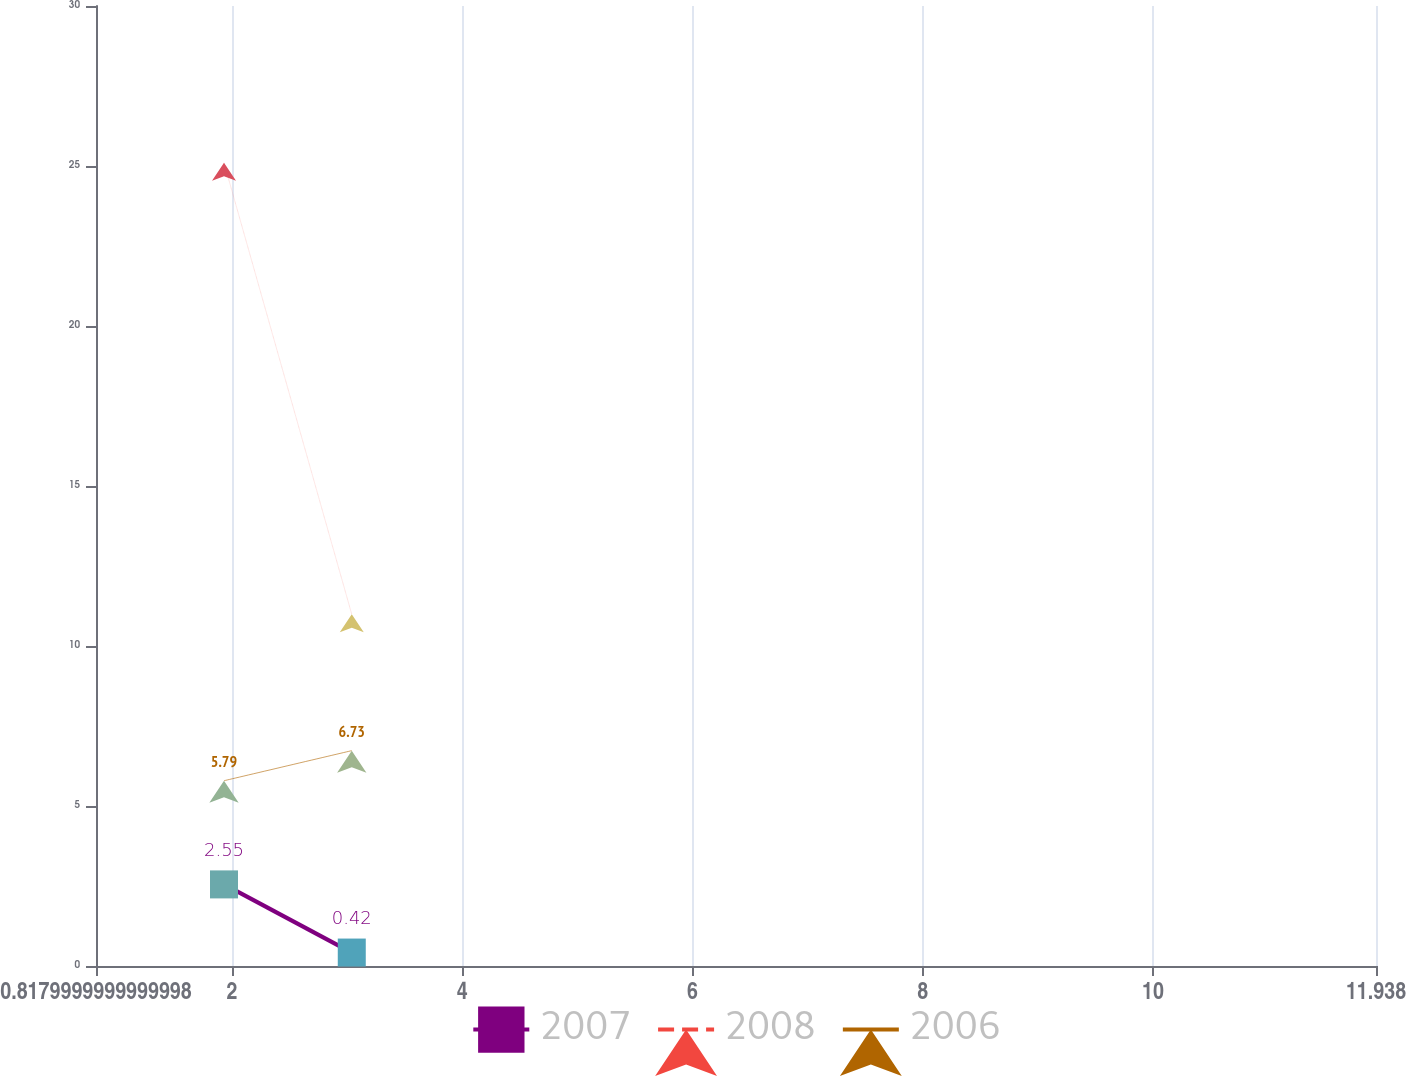Convert chart to OTSL. <chart><loc_0><loc_0><loc_500><loc_500><line_chart><ecel><fcel>2007<fcel>2008<fcel>2006<nl><fcel>1.93<fcel>2.55<fcel>25.1<fcel>5.79<nl><fcel>3.04<fcel>0.42<fcel>10.99<fcel>6.73<nl><fcel>13.05<fcel>0.69<fcel>3.33<fcel>15.2<nl></chart> 